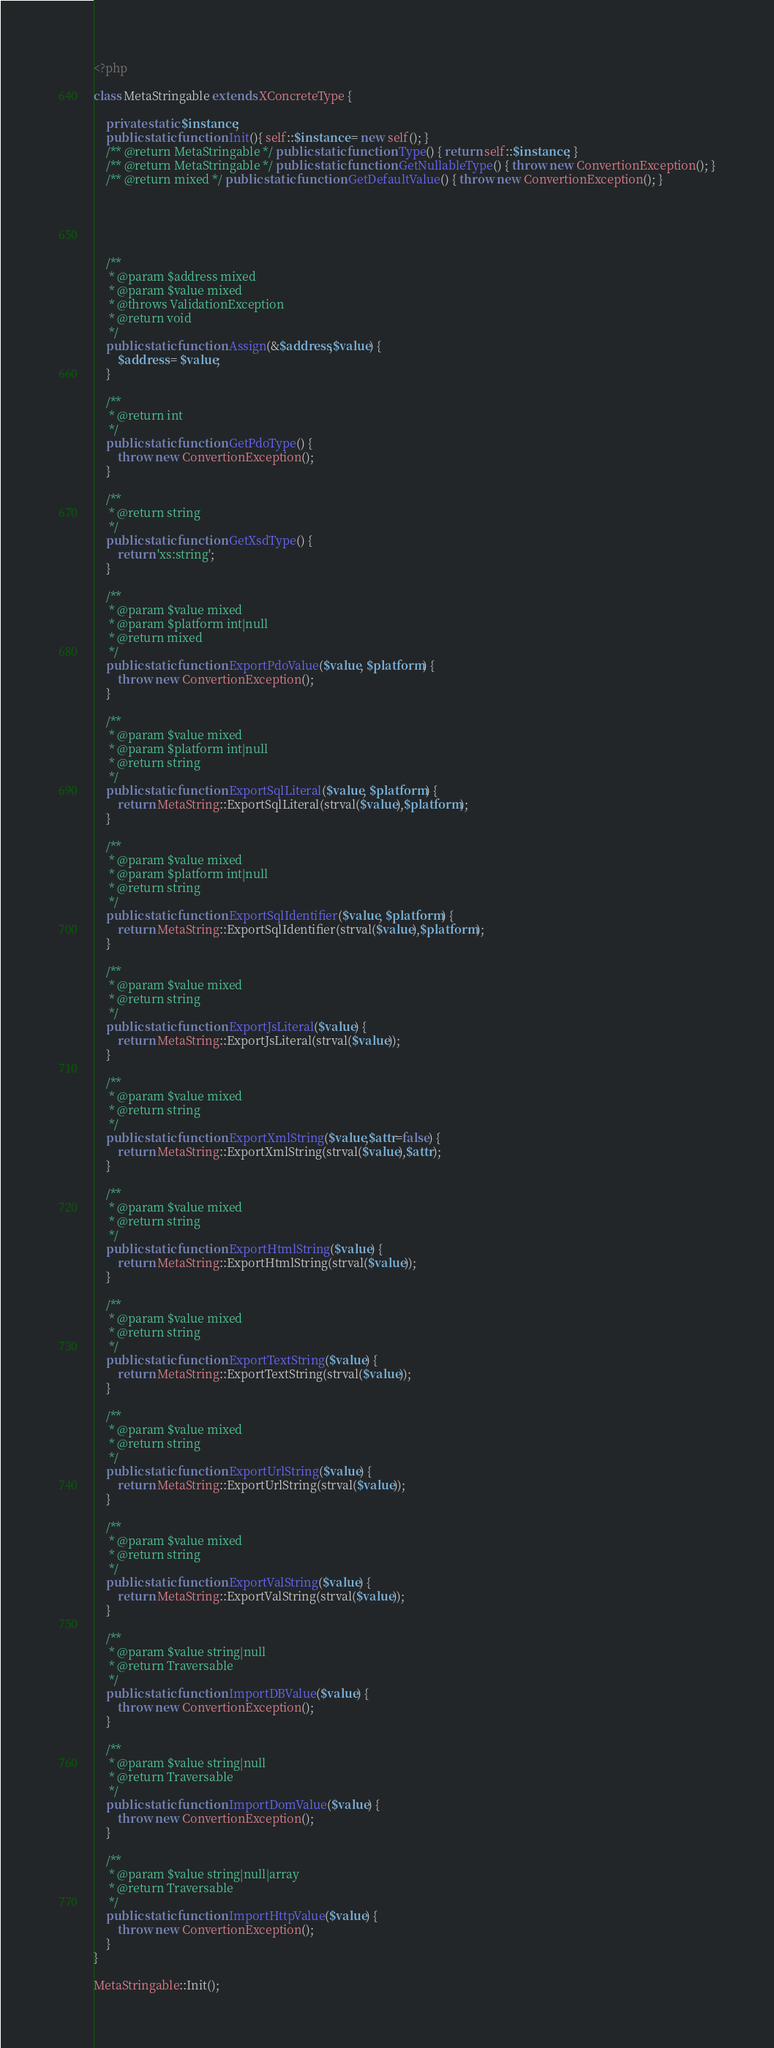Convert code to text. <code><loc_0><loc_0><loc_500><loc_500><_PHP_><?php

class MetaStringable extends XConcreteType {

	private static $instance;
	public static function Init(){ self::$instance = new self(); }
	/** @return MetaStringable */ public static function Type() { return self::$instance; }
	/** @return MetaStringable */ public static function GetNullableType() { throw new ConvertionException(); }
	/** @return mixed */ public static function GetDefaultValue() { throw new ConvertionException(); }




	
	/**
	 * @param $address mixed
	 * @param $value mixed
	 * @throws ValidationException
	 * @return void
	 */
	public static function Assign(&$address,$value) {
		$address = $value;
	}

	/**
	 * @return int
	 */
	public static function GetPdoType() {
		throw new ConvertionException();
	}

	/**
	 * @return string
	 */
	public static function GetXsdType() {
		return 'xs:string';
	}

	/**
	 * @param $value mixed
	 * @param $platform int|null
	 * @return mixed
	 */
	public static function ExportPdoValue($value, $platform) {
		throw new ConvertionException();
	}

	/**
	 * @param $value mixed
	 * @param $platform int|null
	 * @return string
	 */
	public static function ExportSqlLiteral($value, $platform) {
		return MetaString::ExportSqlLiteral(strval($value),$platform);
	}

	/**
	 * @param $value mixed
	 * @param $platform int|null
	 * @return string
	 */
	public static function ExportSqlIdentifier($value, $platform) {
		return MetaString::ExportSqlIdentifier(strval($value),$platform);
	}

	/**
	 * @param $value mixed
	 * @return string
	 */
	public static function ExportJsLiteral($value) {
		return MetaString::ExportJsLiteral(strval($value));
	}

	/**
	 * @param $value mixed
	 * @return string
	 */
	public static function ExportXmlString($value,$attr=false) {
		return MetaString::ExportXmlString(strval($value),$attr);
	}

	/**
	 * @param $value mixed
	 * @return string
	 */
	public static function ExportHtmlString($value) {
		return MetaString::ExportHtmlString(strval($value));
	}

	/**
	 * @param $value mixed
	 * @return string
	 */
	public static function ExportTextString($value) {
		return MetaString::ExportTextString(strval($value));
	}

	/**
	 * @param $value mixed
	 * @return string
	 */
	public static function ExportUrlString($value) {
		return MetaString::ExportUrlString(strval($value));
	}

	/**
	 * @param $value mixed
	 * @return string
	 */
	public static function ExportValString($value) {
		return MetaString::ExportValString(strval($value));
	}

	/**
	 * @param $value string|null
	 * @return Traversable
	 */
	public static function ImportDBValue($value) {
		throw new ConvertionException();
	}

	/**
	 * @param $value string|null
	 * @return Traversable
	 */
	public static function ImportDomValue($value) {
		throw new ConvertionException();
	}

	/**
	 * @param $value string|null|array
	 * @return Traversable
	 */
	public static function ImportHttpValue($value) {
		throw new ConvertionException();
	}
}

MetaStringable::Init();</code> 